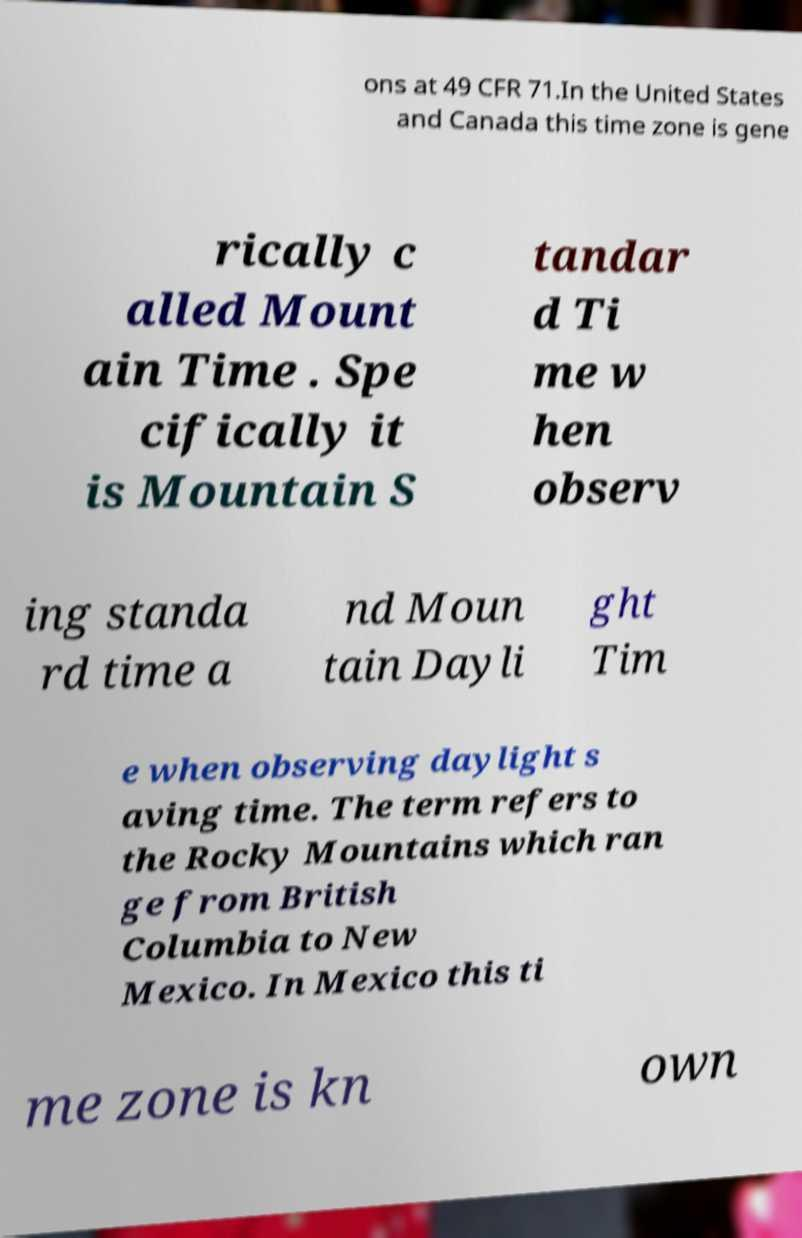What messages or text are displayed in this image? I need them in a readable, typed format. ons at 49 CFR 71.In the United States and Canada this time zone is gene rically c alled Mount ain Time . Spe cifically it is Mountain S tandar d Ti me w hen observ ing standa rd time a nd Moun tain Dayli ght Tim e when observing daylight s aving time. The term refers to the Rocky Mountains which ran ge from British Columbia to New Mexico. In Mexico this ti me zone is kn own 